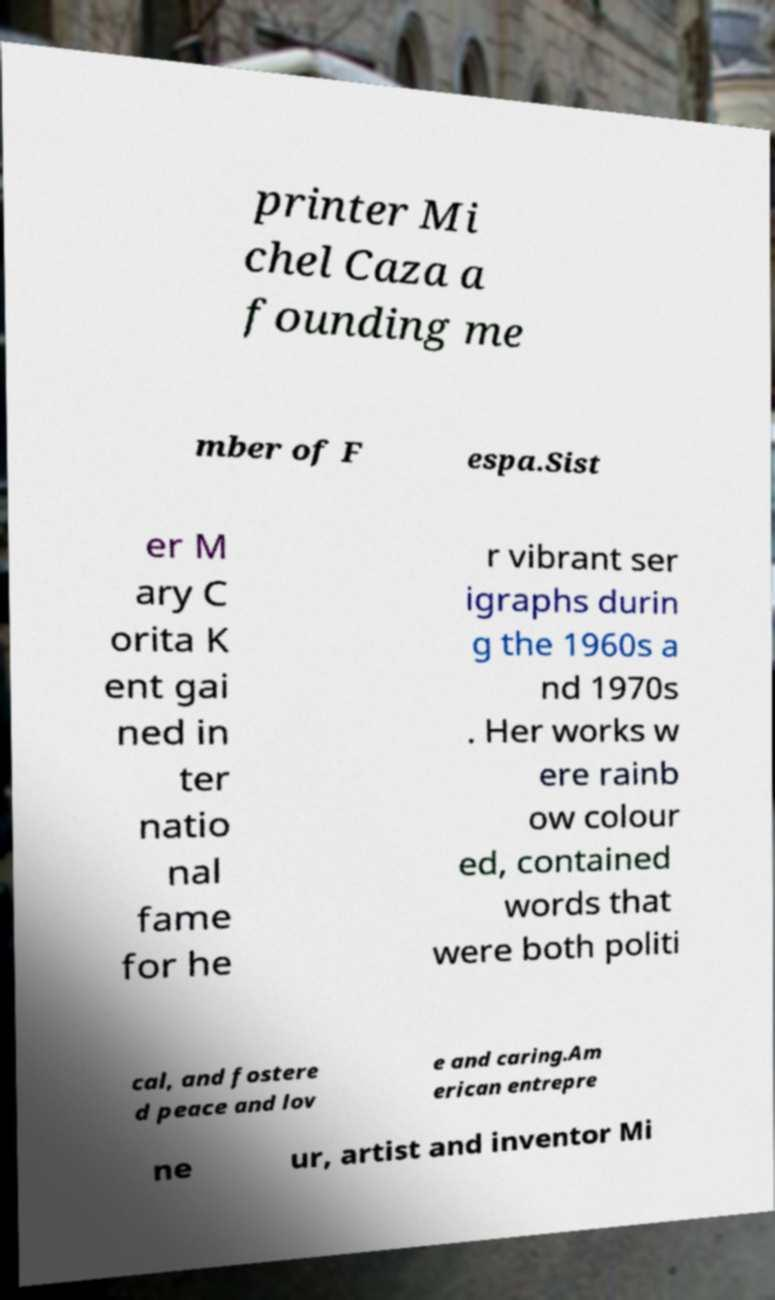There's text embedded in this image that I need extracted. Can you transcribe it verbatim? printer Mi chel Caza a founding me mber of F espa.Sist er M ary C orita K ent gai ned in ter natio nal fame for he r vibrant ser igraphs durin g the 1960s a nd 1970s . Her works w ere rainb ow colour ed, contained words that were both politi cal, and fostere d peace and lov e and caring.Am erican entrepre ne ur, artist and inventor Mi 